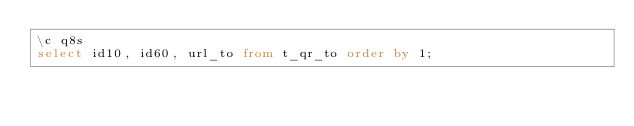Convert code to text. <code><loc_0><loc_0><loc_500><loc_500><_SQL_>\c q8s
select id10, id60, url_to from t_qr_to order by 1;
</code> 